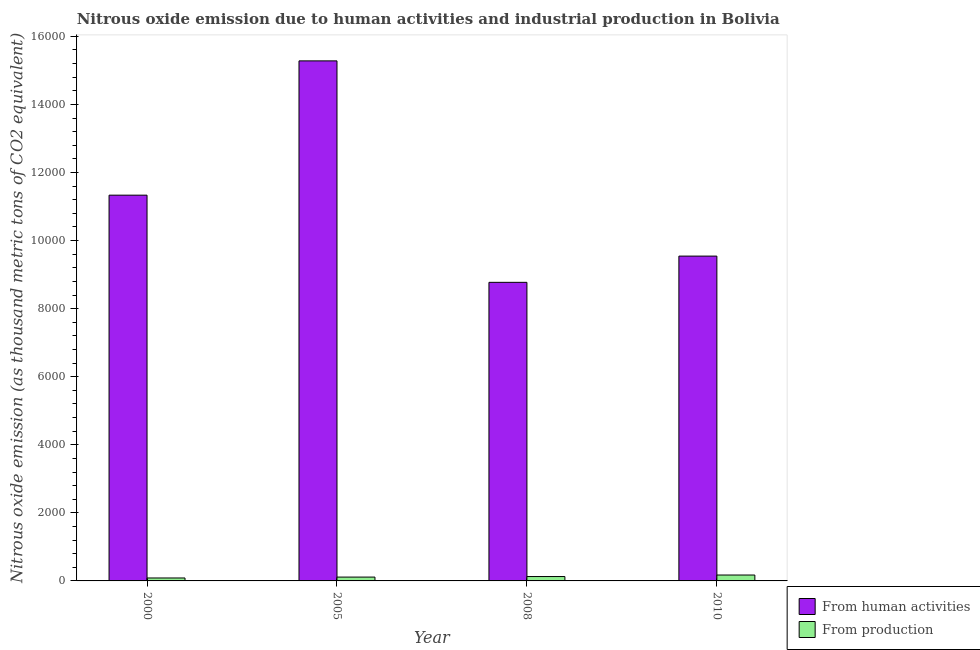How many different coloured bars are there?
Keep it short and to the point. 2. How many groups of bars are there?
Ensure brevity in your answer.  4. Are the number of bars per tick equal to the number of legend labels?
Your answer should be very brief. Yes. How many bars are there on the 1st tick from the left?
Make the answer very short. 2. How many bars are there on the 2nd tick from the right?
Keep it short and to the point. 2. What is the label of the 2nd group of bars from the left?
Offer a terse response. 2005. In how many cases, is the number of bars for a given year not equal to the number of legend labels?
Give a very brief answer. 0. What is the amount of emissions from human activities in 2010?
Your answer should be very brief. 9543.7. Across all years, what is the maximum amount of emissions from human activities?
Your answer should be very brief. 1.53e+04. Across all years, what is the minimum amount of emissions generated from industries?
Give a very brief answer. 86.3. In which year was the amount of emissions from human activities minimum?
Ensure brevity in your answer.  2008. What is the total amount of emissions from human activities in the graph?
Offer a terse response. 4.49e+04. What is the difference between the amount of emissions from human activities in 2000 and that in 2005?
Provide a short and direct response. -3945.4. What is the difference between the amount of emissions from human activities in 2008 and the amount of emissions generated from industries in 2010?
Offer a very short reply. -770.7. What is the average amount of emissions from human activities per year?
Give a very brief answer. 1.12e+04. In the year 2010, what is the difference between the amount of emissions from human activities and amount of emissions generated from industries?
Provide a short and direct response. 0. What is the ratio of the amount of emissions generated from industries in 2000 to that in 2010?
Give a very brief answer. 0.5. Is the amount of emissions generated from industries in 2000 less than that in 2008?
Provide a succinct answer. Yes. What is the difference between the highest and the second highest amount of emissions generated from industries?
Ensure brevity in your answer.  44.3. What is the difference between the highest and the lowest amount of emissions generated from industries?
Offer a terse response. 86.9. In how many years, is the amount of emissions generated from industries greater than the average amount of emissions generated from industries taken over all years?
Give a very brief answer. 2. Is the sum of the amount of emissions generated from industries in 2000 and 2010 greater than the maximum amount of emissions from human activities across all years?
Provide a succinct answer. Yes. What does the 2nd bar from the left in 2008 represents?
Offer a terse response. From production. What does the 1st bar from the right in 2005 represents?
Ensure brevity in your answer.  From production. Are all the bars in the graph horizontal?
Provide a short and direct response. No. How many years are there in the graph?
Give a very brief answer. 4. What is the difference between two consecutive major ticks on the Y-axis?
Offer a very short reply. 2000. Are the values on the major ticks of Y-axis written in scientific E-notation?
Provide a short and direct response. No. Does the graph contain any zero values?
Ensure brevity in your answer.  No. Does the graph contain grids?
Your response must be concise. No. Where does the legend appear in the graph?
Give a very brief answer. Bottom right. What is the title of the graph?
Provide a short and direct response. Nitrous oxide emission due to human activities and industrial production in Bolivia. What is the label or title of the X-axis?
Ensure brevity in your answer.  Year. What is the label or title of the Y-axis?
Make the answer very short. Nitrous oxide emission (as thousand metric tons of CO2 equivalent). What is the Nitrous oxide emission (as thousand metric tons of CO2 equivalent) of From human activities in 2000?
Make the answer very short. 1.13e+04. What is the Nitrous oxide emission (as thousand metric tons of CO2 equivalent) of From production in 2000?
Offer a terse response. 86.3. What is the Nitrous oxide emission (as thousand metric tons of CO2 equivalent) of From human activities in 2005?
Your answer should be very brief. 1.53e+04. What is the Nitrous oxide emission (as thousand metric tons of CO2 equivalent) in From production in 2005?
Provide a short and direct response. 112.7. What is the Nitrous oxide emission (as thousand metric tons of CO2 equivalent) of From human activities in 2008?
Give a very brief answer. 8773. What is the Nitrous oxide emission (as thousand metric tons of CO2 equivalent) in From production in 2008?
Ensure brevity in your answer.  128.9. What is the Nitrous oxide emission (as thousand metric tons of CO2 equivalent) in From human activities in 2010?
Offer a very short reply. 9543.7. What is the Nitrous oxide emission (as thousand metric tons of CO2 equivalent) in From production in 2010?
Offer a terse response. 173.2. Across all years, what is the maximum Nitrous oxide emission (as thousand metric tons of CO2 equivalent) of From human activities?
Your answer should be very brief. 1.53e+04. Across all years, what is the maximum Nitrous oxide emission (as thousand metric tons of CO2 equivalent) of From production?
Ensure brevity in your answer.  173.2. Across all years, what is the minimum Nitrous oxide emission (as thousand metric tons of CO2 equivalent) of From human activities?
Your answer should be very brief. 8773. Across all years, what is the minimum Nitrous oxide emission (as thousand metric tons of CO2 equivalent) in From production?
Keep it short and to the point. 86.3. What is the total Nitrous oxide emission (as thousand metric tons of CO2 equivalent) in From human activities in the graph?
Your response must be concise. 4.49e+04. What is the total Nitrous oxide emission (as thousand metric tons of CO2 equivalent) in From production in the graph?
Give a very brief answer. 501.1. What is the difference between the Nitrous oxide emission (as thousand metric tons of CO2 equivalent) of From human activities in 2000 and that in 2005?
Ensure brevity in your answer.  -3945.4. What is the difference between the Nitrous oxide emission (as thousand metric tons of CO2 equivalent) in From production in 2000 and that in 2005?
Provide a short and direct response. -26.4. What is the difference between the Nitrous oxide emission (as thousand metric tons of CO2 equivalent) of From human activities in 2000 and that in 2008?
Your answer should be very brief. 2561.1. What is the difference between the Nitrous oxide emission (as thousand metric tons of CO2 equivalent) in From production in 2000 and that in 2008?
Provide a succinct answer. -42.6. What is the difference between the Nitrous oxide emission (as thousand metric tons of CO2 equivalent) in From human activities in 2000 and that in 2010?
Offer a very short reply. 1790.4. What is the difference between the Nitrous oxide emission (as thousand metric tons of CO2 equivalent) of From production in 2000 and that in 2010?
Your answer should be compact. -86.9. What is the difference between the Nitrous oxide emission (as thousand metric tons of CO2 equivalent) in From human activities in 2005 and that in 2008?
Your response must be concise. 6506.5. What is the difference between the Nitrous oxide emission (as thousand metric tons of CO2 equivalent) in From production in 2005 and that in 2008?
Provide a succinct answer. -16.2. What is the difference between the Nitrous oxide emission (as thousand metric tons of CO2 equivalent) in From human activities in 2005 and that in 2010?
Your answer should be compact. 5735.8. What is the difference between the Nitrous oxide emission (as thousand metric tons of CO2 equivalent) of From production in 2005 and that in 2010?
Give a very brief answer. -60.5. What is the difference between the Nitrous oxide emission (as thousand metric tons of CO2 equivalent) in From human activities in 2008 and that in 2010?
Keep it short and to the point. -770.7. What is the difference between the Nitrous oxide emission (as thousand metric tons of CO2 equivalent) of From production in 2008 and that in 2010?
Keep it short and to the point. -44.3. What is the difference between the Nitrous oxide emission (as thousand metric tons of CO2 equivalent) of From human activities in 2000 and the Nitrous oxide emission (as thousand metric tons of CO2 equivalent) of From production in 2005?
Your response must be concise. 1.12e+04. What is the difference between the Nitrous oxide emission (as thousand metric tons of CO2 equivalent) of From human activities in 2000 and the Nitrous oxide emission (as thousand metric tons of CO2 equivalent) of From production in 2008?
Your answer should be very brief. 1.12e+04. What is the difference between the Nitrous oxide emission (as thousand metric tons of CO2 equivalent) of From human activities in 2000 and the Nitrous oxide emission (as thousand metric tons of CO2 equivalent) of From production in 2010?
Provide a succinct answer. 1.12e+04. What is the difference between the Nitrous oxide emission (as thousand metric tons of CO2 equivalent) of From human activities in 2005 and the Nitrous oxide emission (as thousand metric tons of CO2 equivalent) of From production in 2008?
Offer a terse response. 1.52e+04. What is the difference between the Nitrous oxide emission (as thousand metric tons of CO2 equivalent) in From human activities in 2005 and the Nitrous oxide emission (as thousand metric tons of CO2 equivalent) in From production in 2010?
Give a very brief answer. 1.51e+04. What is the difference between the Nitrous oxide emission (as thousand metric tons of CO2 equivalent) of From human activities in 2008 and the Nitrous oxide emission (as thousand metric tons of CO2 equivalent) of From production in 2010?
Your response must be concise. 8599.8. What is the average Nitrous oxide emission (as thousand metric tons of CO2 equivalent) in From human activities per year?
Offer a very short reply. 1.12e+04. What is the average Nitrous oxide emission (as thousand metric tons of CO2 equivalent) in From production per year?
Make the answer very short. 125.28. In the year 2000, what is the difference between the Nitrous oxide emission (as thousand metric tons of CO2 equivalent) of From human activities and Nitrous oxide emission (as thousand metric tons of CO2 equivalent) of From production?
Keep it short and to the point. 1.12e+04. In the year 2005, what is the difference between the Nitrous oxide emission (as thousand metric tons of CO2 equivalent) in From human activities and Nitrous oxide emission (as thousand metric tons of CO2 equivalent) in From production?
Offer a very short reply. 1.52e+04. In the year 2008, what is the difference between the Nitrous oxide emission (as thousand metric tons of CO2 equivalent) of From human activities and Nitrous oxide emission (as thousand metric tons of CO2 equivalent) of From production?
Your response must be concise. 8644.1. In the year 2010, what is the difference between the Nitrous oxide emission (as thousand metric tons of CO2 equivalent) of From human activities and Nitrous oxide emission (as thousand metric tons of CO2 equivalent) of From production?
Provide a succinct answer. 9370.5. What is the ratio of the Nitrous oxide emission (as thousand metric tons of CO2 equivalent) of From human activities in 2000 to that in 2005?
Keep it short and to the point. 0.74. What is the ratio of the Nitrous oxide emission (as thousand metric tons of CO2 equivalent) in From production in 2000 to that in 2005?
Make the answer very short. 0.77. What is the ratio of the Nitrous oxide emission (as thousand metric tons of CO2 equivalent) of From human activities in 2000 to that in 2008?
Make the answer very short. 1.29. What is the ratio of the Nitrous oxide emission (as thousand metric tons of CO2 equivalent) of From production in 2000 to that in 2008?
Provide a short and direct response. 0.67. What is the ratio of the Nitrous oxide emission (as thousand metric tons of CO2 equivalent) in From human activities in 2000 to that in 2010?
Ensure brevity in your answer.  1.19. What is the ratio of the Nitrous oxide emission (as thousand metric tons of CO2 equivalent) of From production in 2000 to that in 2010?
Your answer should be compact. 0.5. What is the ratio of the Nitrous oxide emission (as thousand metric tons of CO2 equivalent) in From human activities in 2005 to that in 2008?
Provide a succinct answer. 1.74. What is the ratio of the Nitrous oxide emission (as thousand metric tons of CO2 equivalent) in From production in 2005 to that in 2008?
Your answer should be compact. 0.87. What is the ratio of the Nitrous oxide emission (as thousand metric tons of CO2 equivalent) in From human activities in 2005 to that in 2010?
Keep it short and to the point. 1.6. What is the ratio of the Nitrous oxide emission (as thousand metric tons of CO2 equivalent) of From production in 2005 to that in 2010?
Give a very brief answer. 0.65. What is the ratio of the Nitrous oxide emission (as thousand metric tons of CO2 equivalent) of From human activities in 2008 to that in 2010?
Your response must be concise. 0.92. What is the ratio of the Nitrous oxide emission (as thousand metric tons of CO2 equivalent) of From production in 2008 to that in 2010?
Your response must be concise. 0.74. What is the difference between the highest and the second highest Nitrous oxide emission (as thousand metric tons of CO2 equivalent) of From human activities?
Offer a terse response. 3945.4. What is the difference between the highest and the second highest Nitrous oxide emission (as thousand metric tons of CO2 equivalent) of From production?
Make the answer very short. 44.3. What is the difference between the highest and the lowest Nitrous oxide emission (as thousand metric tons of CO2 equivalent) in From human activities?
Give a very brief answer. 6506.5. What is the difference between the highest and the lowest Nitrous oxide emission (as thousand metric tons of CO2 equivalent) of From production?
Your answer should be compact. 86.9. 